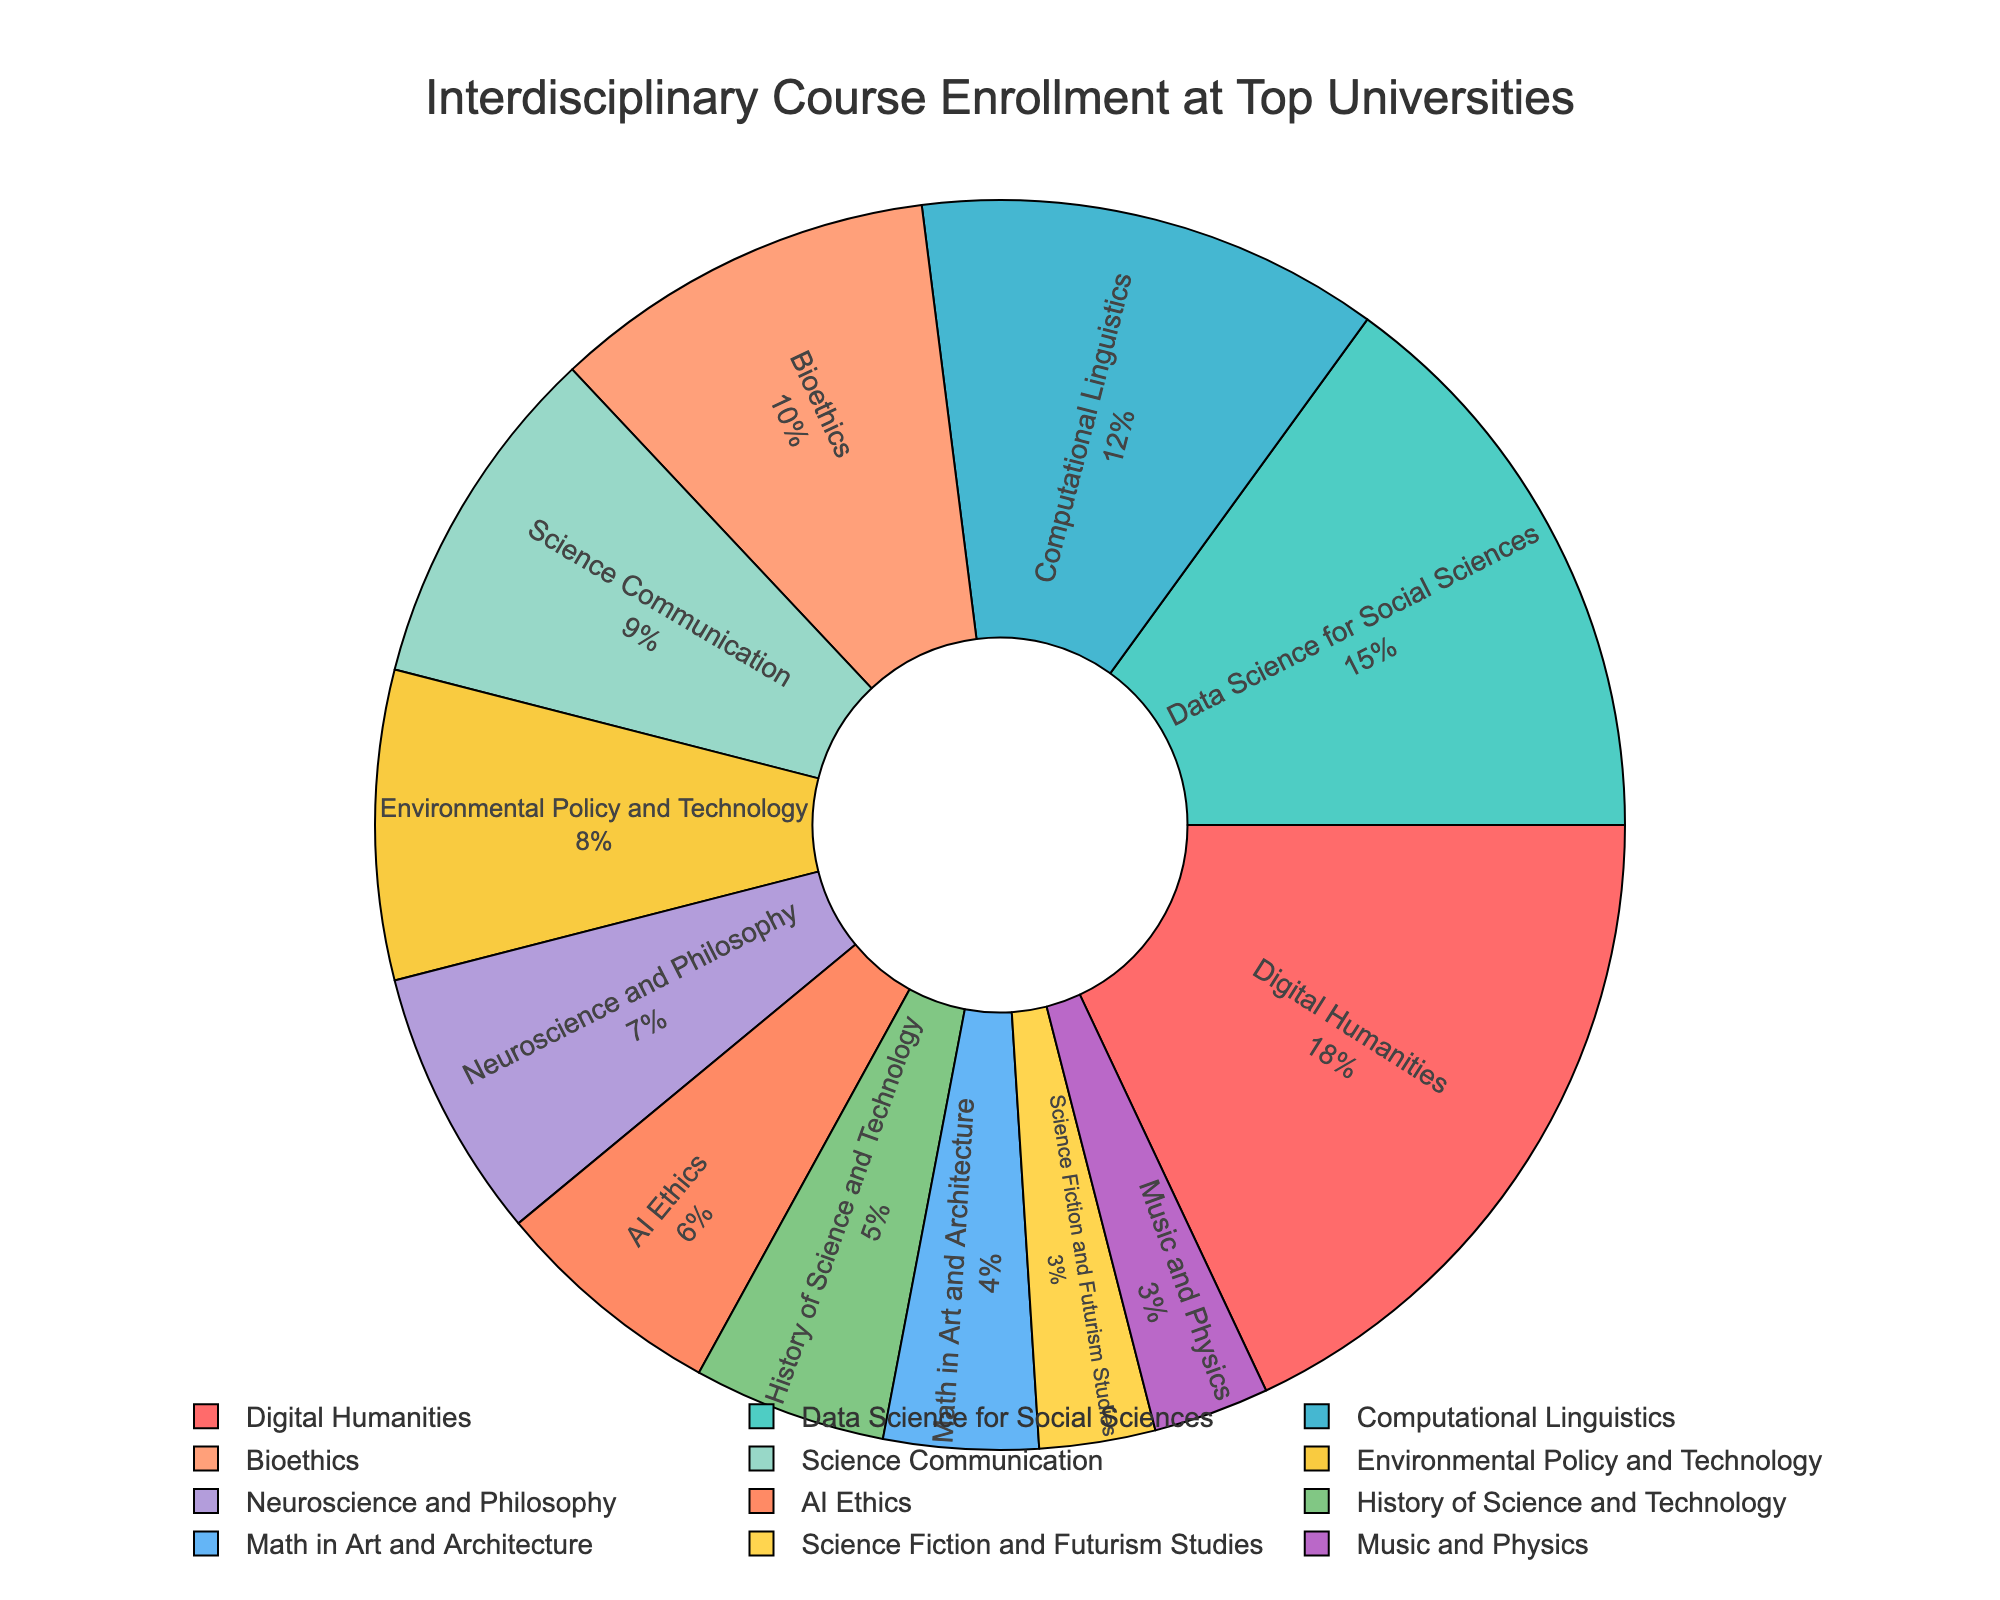What is the largest enrollment percentage and for which course? The largest percentage is visually identifiable as the largest segment of the pie chart. It is labeled "Digital Humanities" with 18%.
Answer: 18% for Digital Humanities Which two courses have the smallest enrollment percentages? By looking at the smallest segments of the pie chart, we identify "Science Fiction and Futurism Studies" and "Music and Physics," both marked at 3%.
Answer: Science Fiction and Futurism Studies and Music and Physics How much greater is the enrollment percentage for Data Science for Social Sciences compared to AI Ethics? Data Science for Social Sciences is 15%, and AI Ethics is 6%. The difference is calculated as 15%-6%=9%.
Answer: 9% What is the total combined percentage for the top three courses? The top three courses by enrollment percentage are Digital Humanities (18%), Data Science for Social Sciences (15%), and Computational Linguistics (12%). Adding them gives 18% + 15% + 12% = 45%.
Answer: 45% Which course has a higher enrollment, Bioethics or Science Communication? By comparing the segments for Bioethics (10%) and Science Communication (9%), we see that Bioethics has a slightly higher enrollment percentage.
Answer: Bioethics Identify the course with a purple segment and provide its percentage. The purple segment visually corresponds to Computational Linguistics, which has a 12% enrollment percentage.
Answer: Computational Linguistics, 12% What is the combined enrollment for courses with percentages below 5%? The courses with less than 5% enrollment are History of Science and Technology (5%), Math in Art and Architecture (4%), Science Fiction and Futurism Studies (3%), and Music and Physics (3%). Adding their percentages gives 5% + 4% + 3% + 3% = 15%.
Answer: 15% Which two courses together account for over 30% of the enrollment? The two largest sectors in the pie chart are Digital Humanities (18%) and Data Science for Social Sciences (15%). Their combined percentage is 18% + 15% = 33%, over 30%.
Answer: Digital Humanities and Data Science for Social Sciences How does the enrollment percentage of Computational Linguistics compare to Environmental Policy and Technology? Computational Linguistics has a higher enrollment percentage at 12%, compared to Environmental Policy and Technology at 8%.
Answer: Computational Linguistics is higher What is the average enrollment for the courses with the smallest three percentages? The smallest three percentages are for Science Fiction and Futurism Studies (3%), Music and Physics (3%), and Math in Art and Architecture (4%). The average is (3% + 3% + 4%) / 3 = 10% / 3 = 3.33%.
Answer: 3.33% 